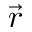Convert formula to latex. <formula><loc_0><loc_0><loc_500><loc_500>\vec { r }</formula> 